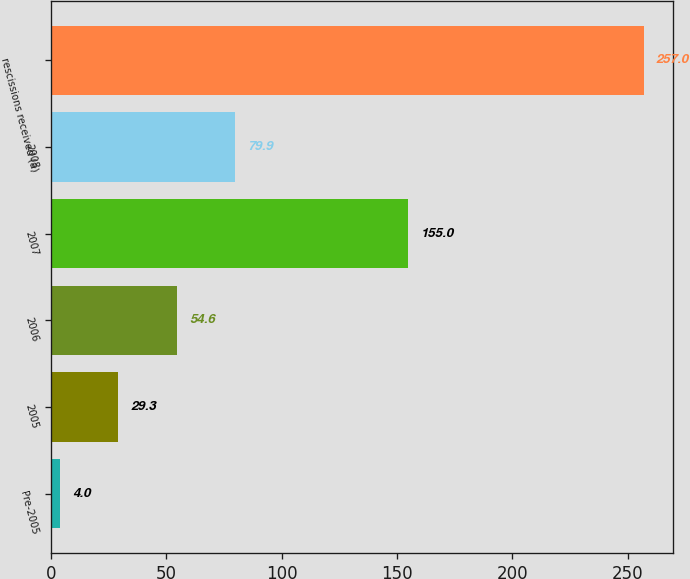Convert chart. <chart><loc_0><loc_0><loc_500><loc_500><bar_chart><fcel>Pre-2005<fcel>2005<fcel>2006<fcel>2007<fcel>2008<fcel>rescissions received (a)<nl><fcel>4<fcel>29.3<fcel>54.6<fcel>155<fcel>79.9<fcel>257<nl></chart> 